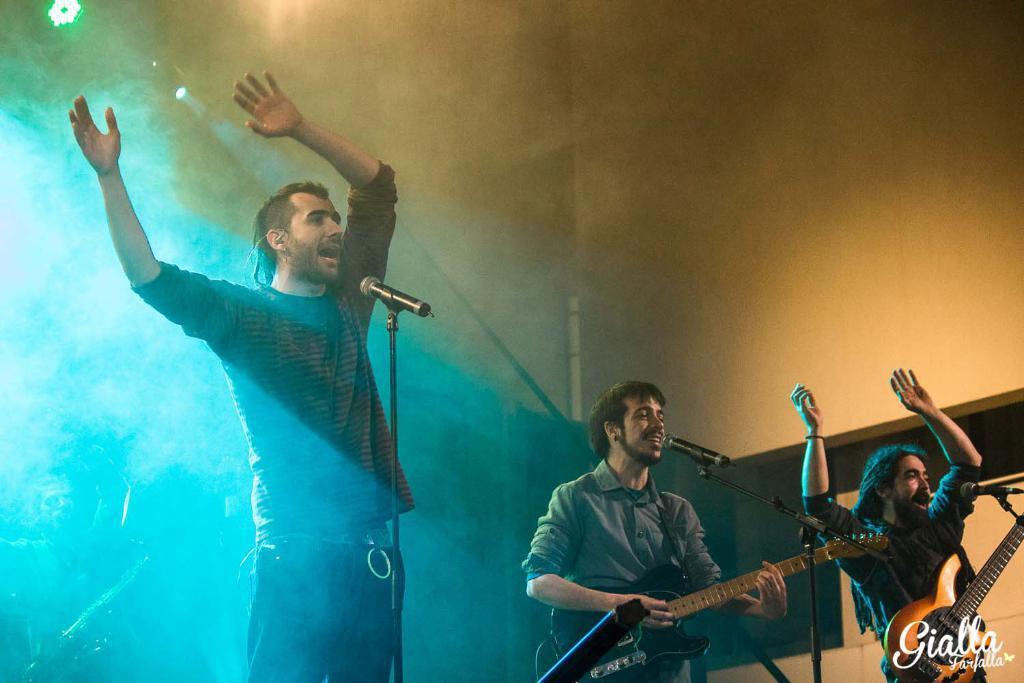In one or two sentences, can you explain what this image depicts? In this image I see 3 men, in which 2 of them are holding guitars and there are mics in front of them. In the background I can see a light and the wall. 